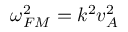Convert formula to latex. <formula><loc_0><loc_0><loc_500><loc_500>\omega _ { F M } ^ { 2 } = k ^ { 2 } v _ { A } ^ { 2 }</formula> 